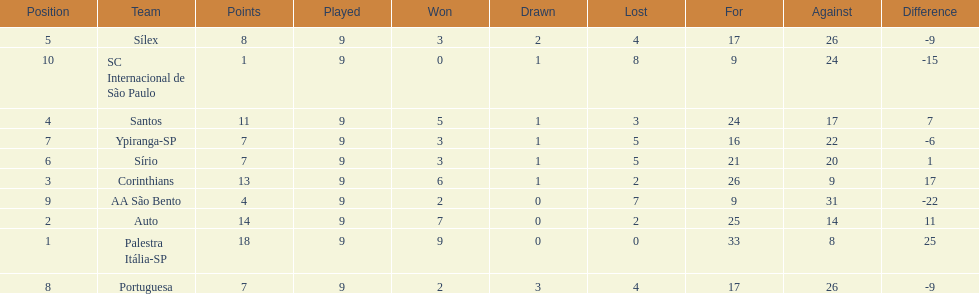In 1926 brazilian football,what was the total number of points scored? 90. 